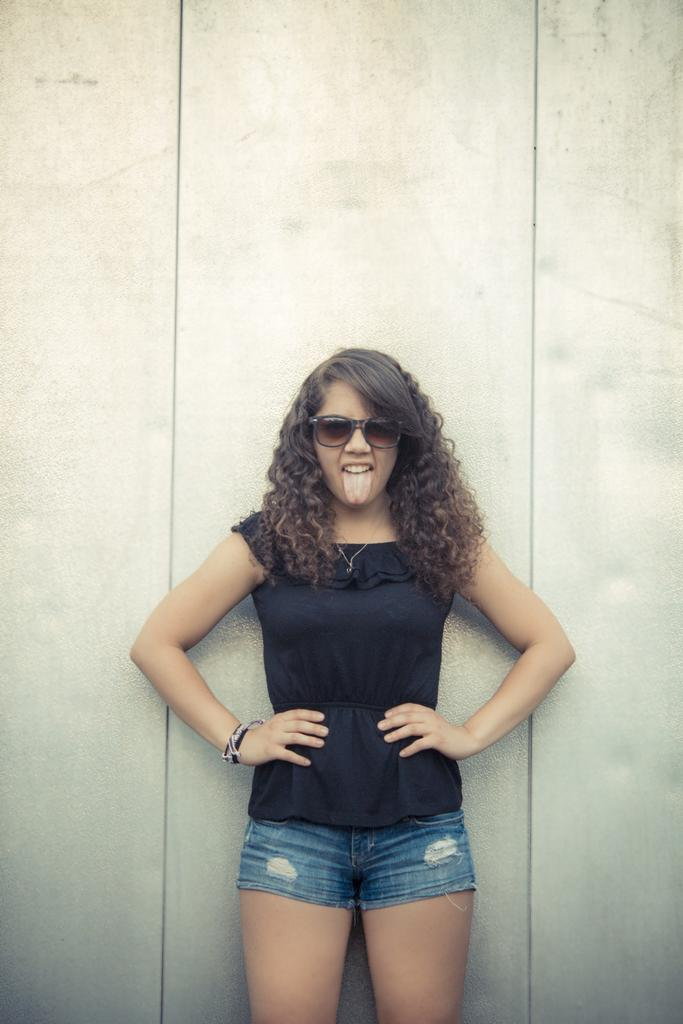Who is the main subject in the image? There is a girl in the image. What is the girl wearing on her upper body? The girl is wearing a black color top. What type of pants is the girl wearing? The girl is wearing blue color jeans short. What appliance is the girl using in the image? There is no appliance visible in the image; it only shows the girl wearing a black top and blue jeans short. 